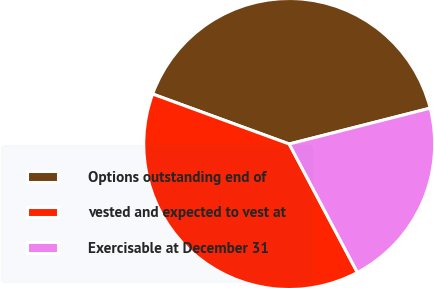Convert chart. <chart><loc_0><loc_0><loc_500><loc_500><pie_chart><fcel>Options outstanding end of<fcel>vested and expected to vest at<fcel>Exercisable at December 31<nl><fcel>40.45%<fcel>38.35%<fcel>21.2%<nl></chart> 